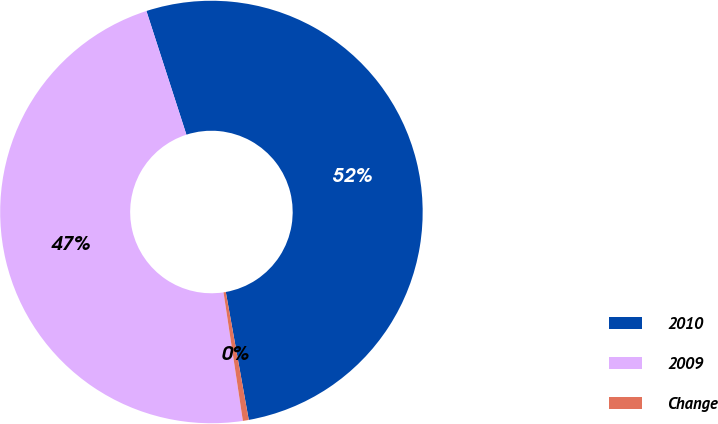Convert chart to OTSL. <chart><loc_0><loc_0><loc_500><loc_500><pie_chart><fcel>2010<fcel>2009<fcel>Change<nl><fcel>52.15%<fcel>47.4%<fcel>0.45%<nl></chart> 